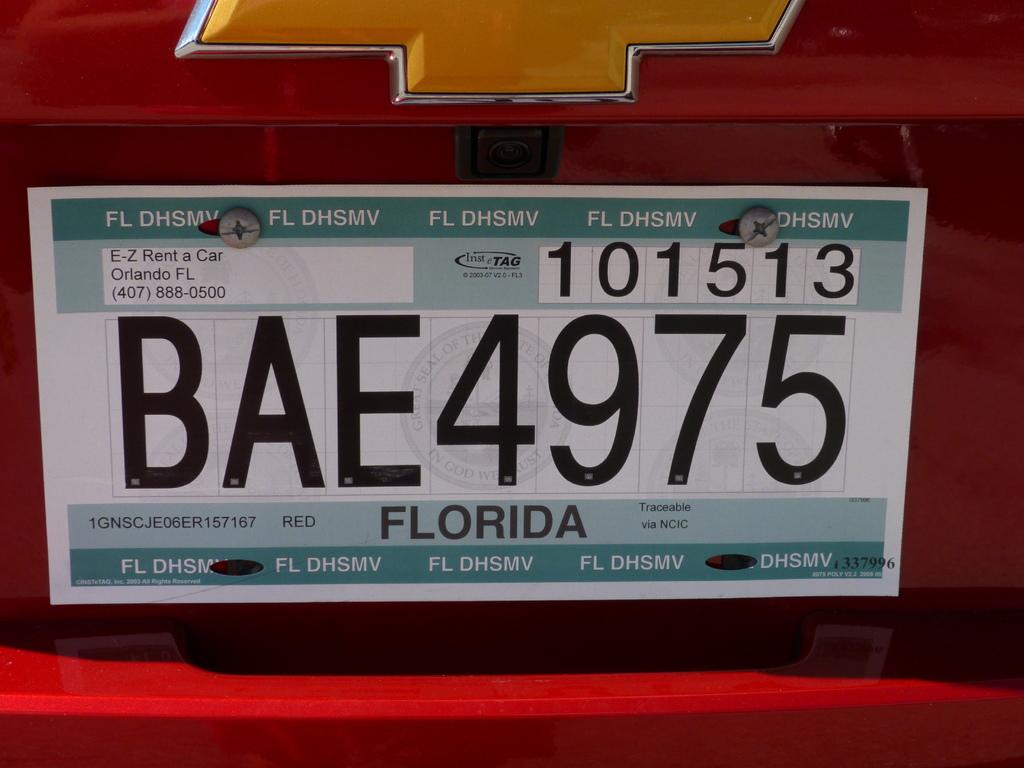Which company is the car rented from?
Keep it short and to the point. E-z rent a car. 